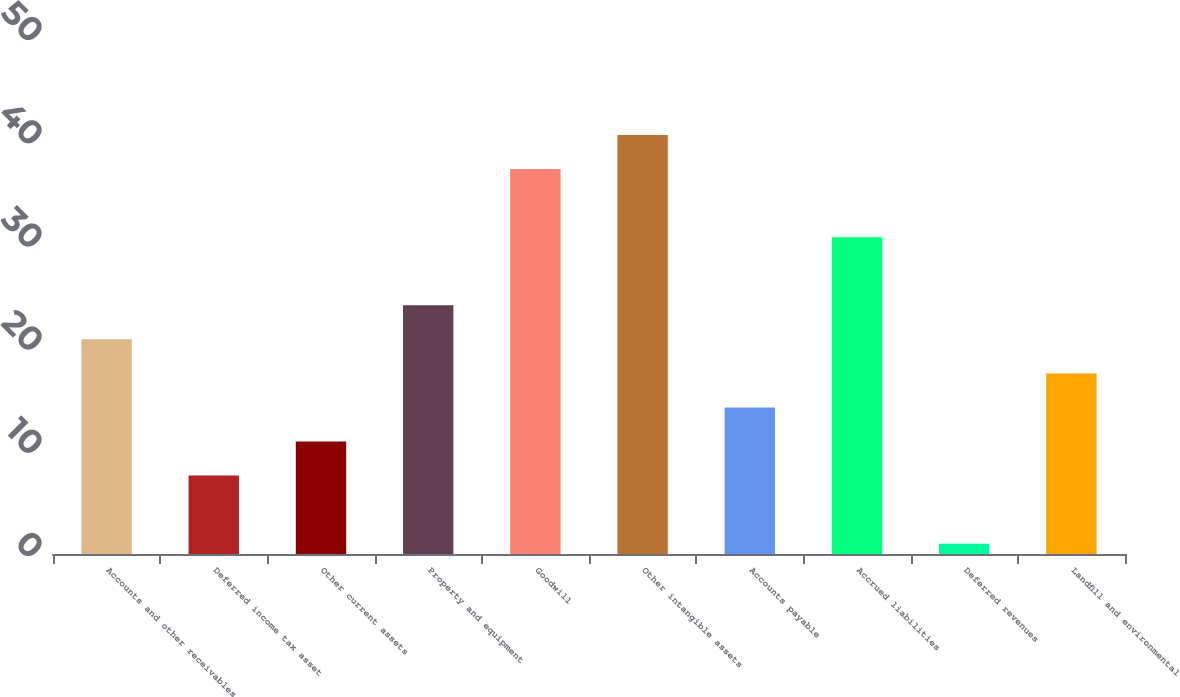<chart> <loc_0><loc_0><loc_500><loc_500><bar_chart><fcel>Accounts and other receivables<fcel>Deferred income tax asset<fcel>Other current assets<fcel>Property and equipment<fcel>Goodwill<fcel>Other intangible assets<fcel>Accounts payable<fcel>Accrued liabilities<fcel>Deferred revenues<fcel>Landfill and environmental<nl><fcel>20.8<fcel>7.6<fcel>10.9<fcel>24.1<fcel>37.3<fcel>40.6<fcel>14.2<fcel>30.7<fcel>1<fcel>17.5<nl></chart> 